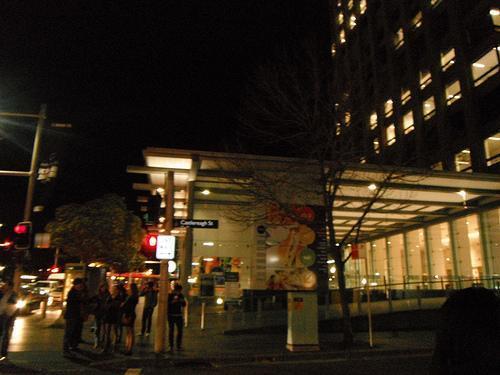How many people are waiting to cross the street?
Give a very brief answer. 8. How many red lights are lit in the night scene?
Give a very brief answer. 2. 